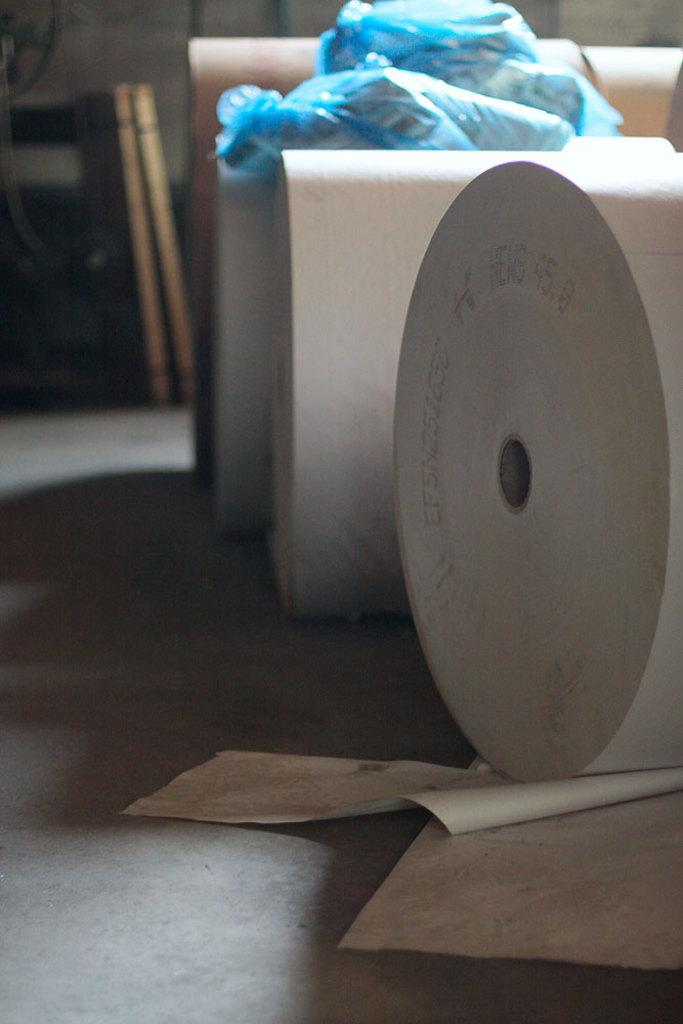What is on the floor in the image? There are paper rolls on the floor. What is on the paper rolls? There are bags on the paper rolls. What can be seen on the left side of the image? There are wooden planks on the left side of the image. What type of carriage is being pulled by the horses in the image? There are no horses or carriages present in the image; it features paper rolls, bags, and wooden planks. What act is being performed by the people in the image? There are no people or acts being performed in the image; it only shows paper rolls, bags, and wooden planks. 